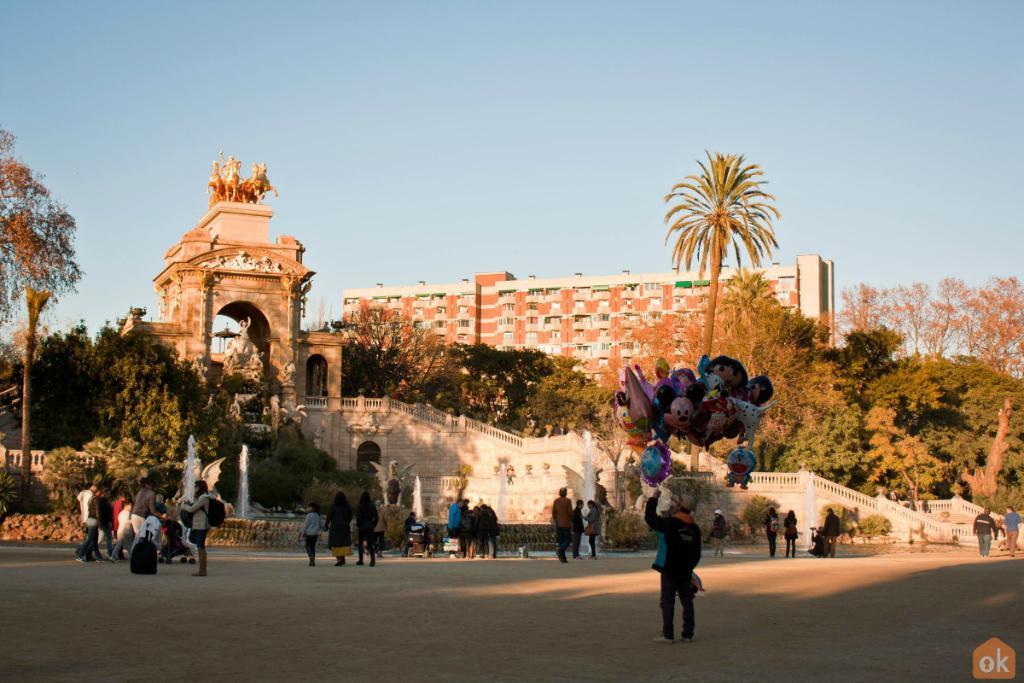Please provide a concise description of this image. In this picture there is a man who is holding the balloons. In the back I can see many people who are walking on the street. Beside them I can see the monuments structure. On the right I can see the stairs and railing. Behind the stairs I can see the trees, plants and grass. In the background I can see the building. At the top I can see the sky. At the top of the moment I can see the statues. 